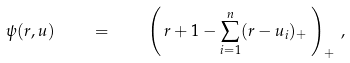<formula> <loc_0><loc_0><loc_500><loc_500>\psi ( r , u ) \quad = \quad \left ( \, r + 1 - \sum _ { i = 1 } ^ { n } ( r - u _ { i } ) _ { + } \, \right ) _ { + } \, ,</formula> 